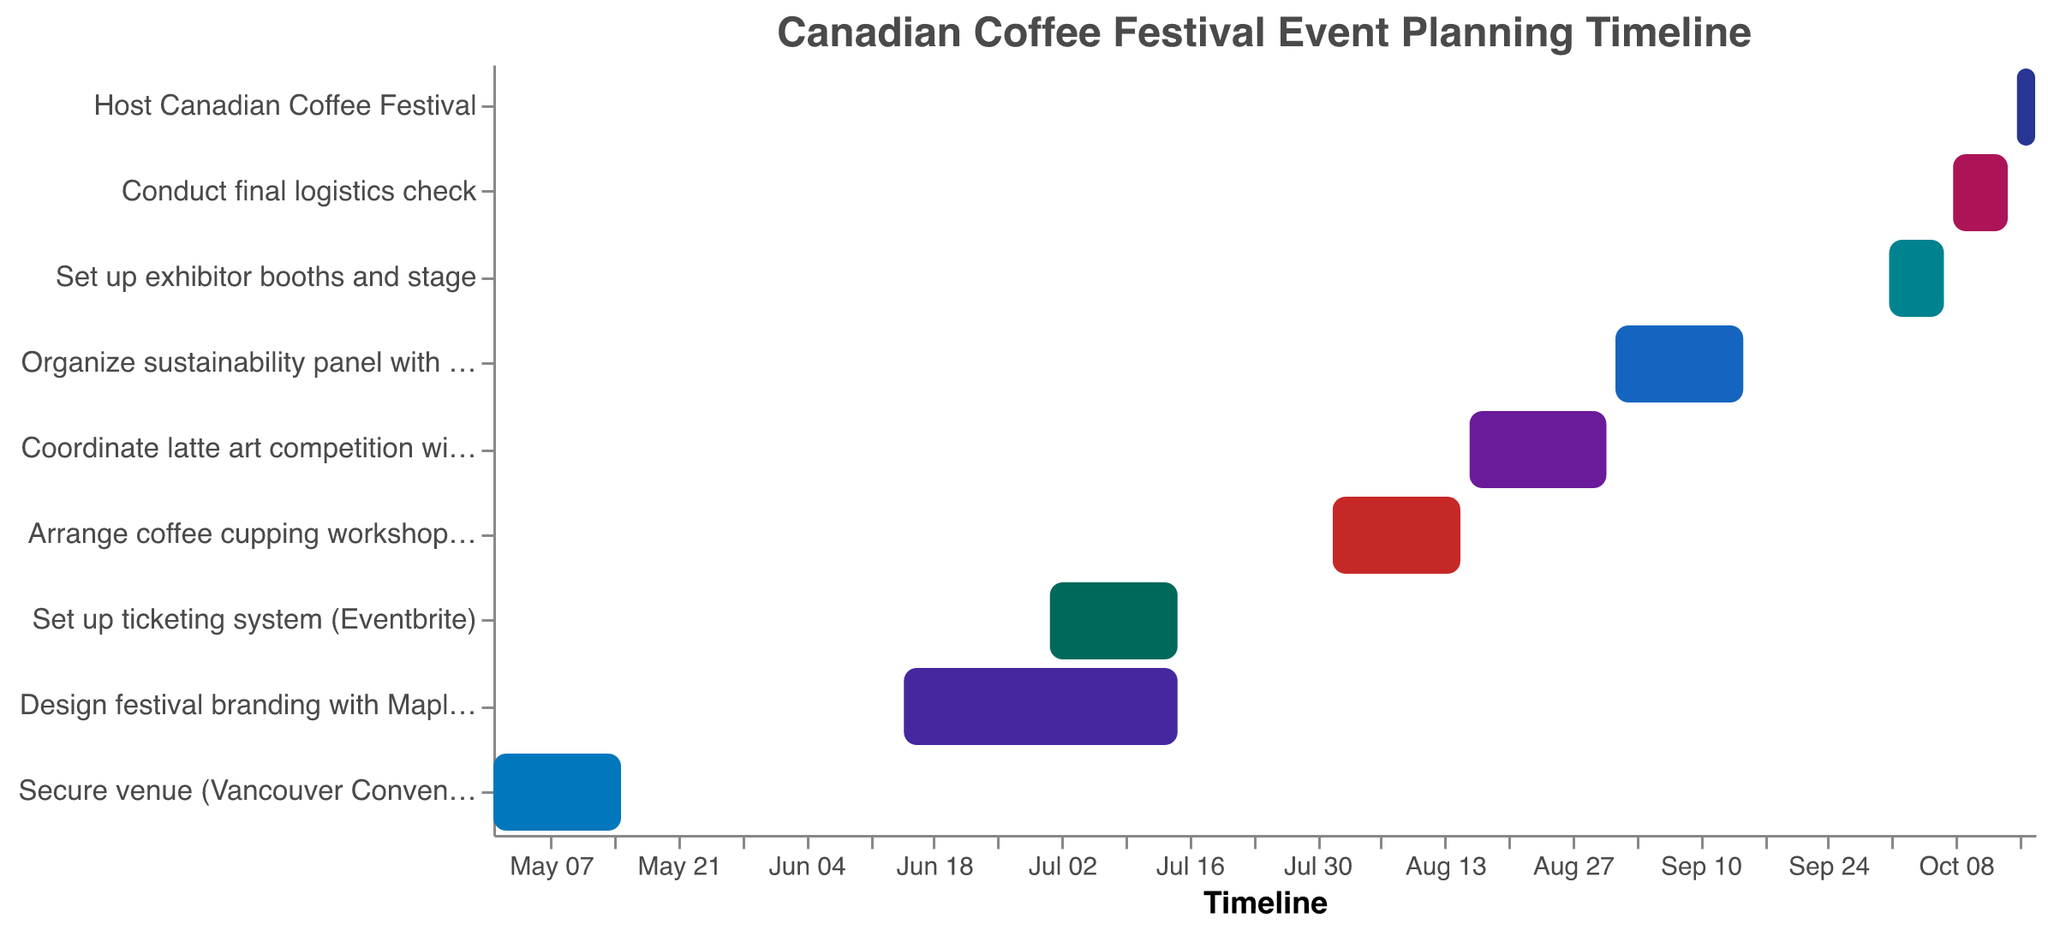What is the title of the Gantt Chart? The chart's title is displayed at the top and is formatted in a larger, distinguishing font.
Answer: Canadian Coffee Festival Event Planning Timeline What are the start and end dates for the task "Design festival branding with Maple Leaf motif"? The chart uses bars to display the start and end dates for each task, and labels each bar with the corresponding task.
Answer: Start Date: June 15, 2023; End Date: July 15, 2023 Which task has the shortest duration? To determine the task with the shortest duration, compare the length of the bars in the Gantt chart and count the days between the start and end dates. The shortest bar corresponds to the shortest duration.
Answer: Conduct final logistics check Which task starts immediately after "Arrange coffee cupping workshops with Second Cup"? Look for the task labeled "Arrange coffee cupping workshops with Second Cup" and check which task has a start date immediately following the end date of this task.
Answer: Coordinate latte art competition with Blenz Coffee Does any task start before June 2023? Review the start dates for each task depicted in the chart and identify if any task's start date occurs before June.
Answer: Yes, "Secure venue (Vancouver Convention Centre)" starts on May 1, 2023 How long does it take to coordinate the latte art competition with Blenz Coffee? Calculate the number of days between the start and end dates by doing simple subtraction.
Answer: 16 days Which two tasks overlap in August 2023? Examine the timeline for August and identify which tasks have time spans crossing over the same date range in August.
Answer: Arrange coffee cupping workshops with Second Cup and Coordinate latte art competition with Blenz Coffee What is the total number of days allotted for setting up exhibitor booths and the final logistics check? Add the number of days for "Set up exhibitor booths and stage" and "Conduct final logistics check" by calculating the days between their respective start and end dates and summing them up.
Answer: 13 days Do any tasks occur simultaneously with the festival? Check the dates for "Host Canadian Coffee Festival" and identify if any tasks have overlapping periods with the festival dates.
Answer: No In what month is the sustainability panel with Tim Hortons scheduled? Check the start and end dates for the "Organize sustainability panel with Tim Hortons" and identify the month within its date range.
Answer: September 